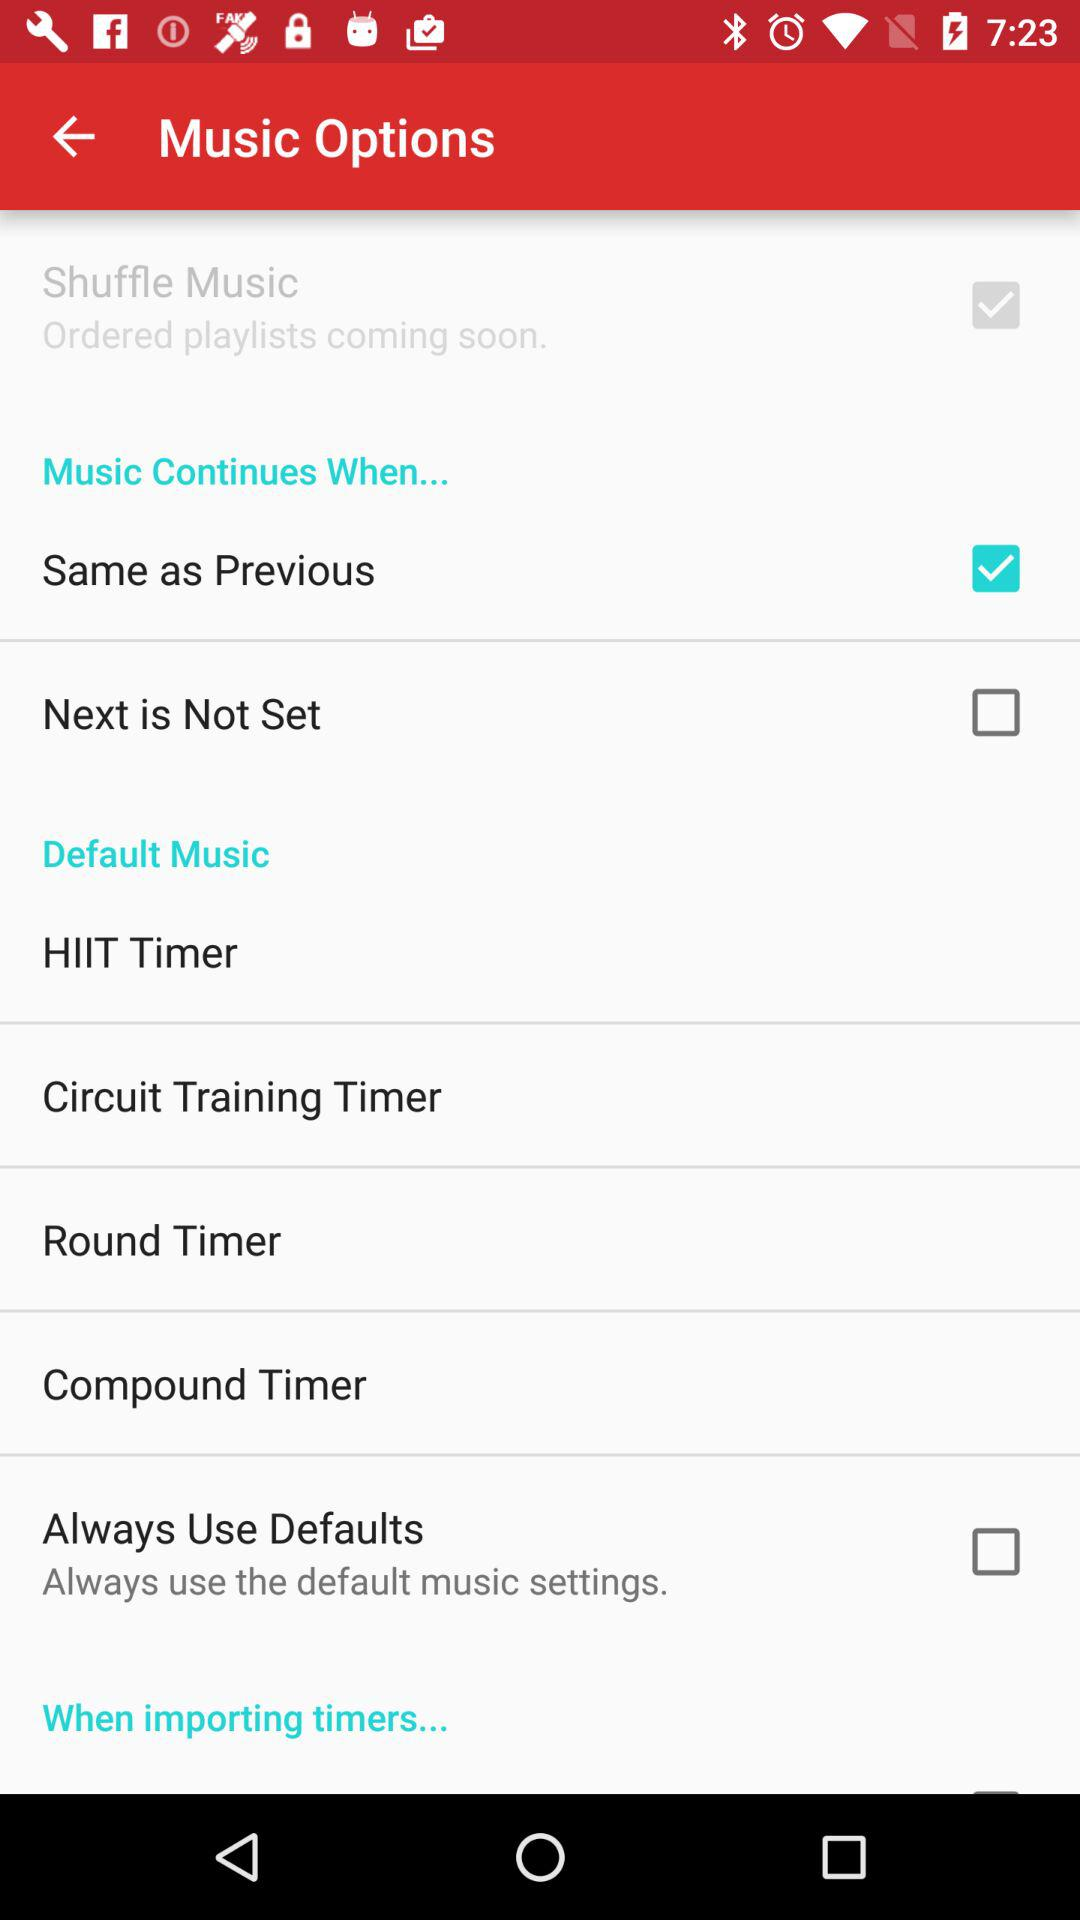What is the status of "Same as Previous"? The status of "Same as Previous" is "on". 